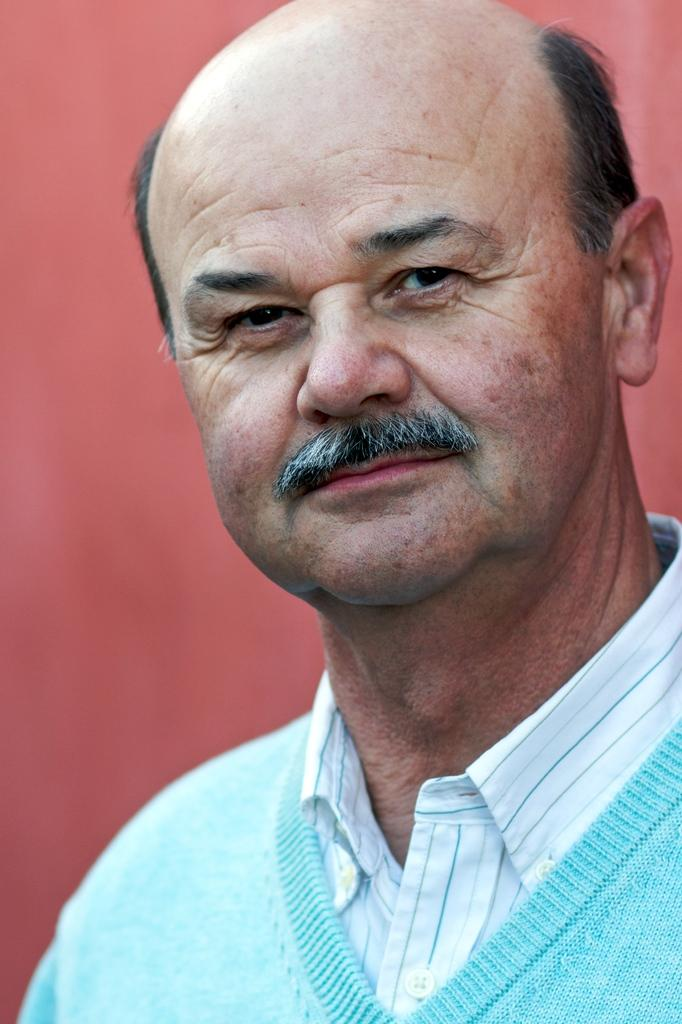What is the main subject of the image? The main subject of the image is a man. What type of company does the man work for in the image? There is no information about a company or the man's occupation in the image. Can you see any worms crawling on the man in the image? There are no worms present in the image. 